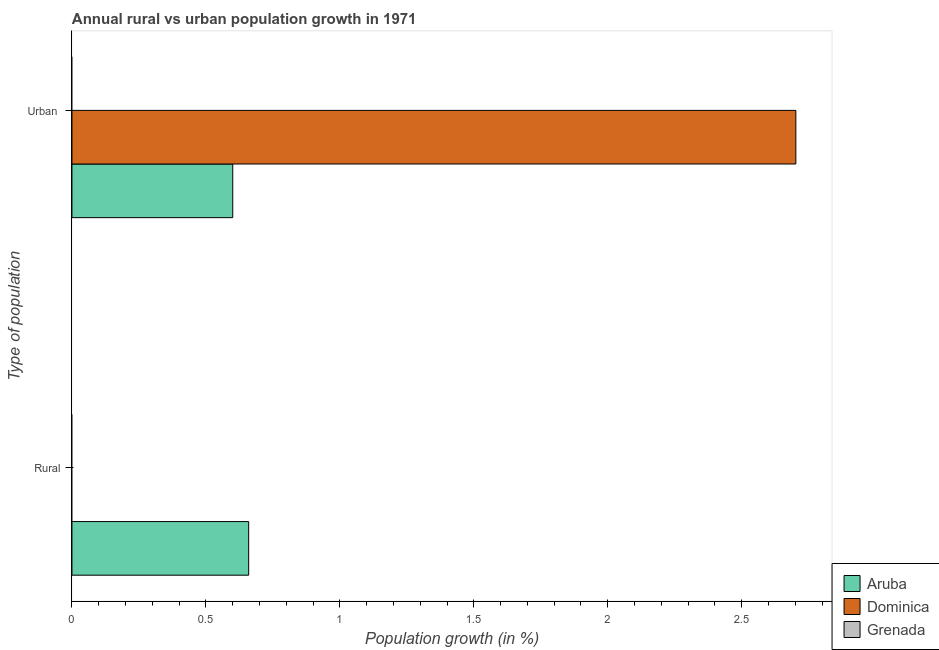Are the number of bars per tick equal to the number of legend labels?
Provide a succinct answer. No. What is the label of the 1st group of bars from the top?
Provide a succinct answer. Urban . Across all countries, what is the maximum rural population growth?
Offer a very short reply. 0.66. In which country was the urban population growth maximum?
Provide a succinct answer. Dominica. What is the total urban population growth in the graph?
Keep it short and to the point. 3.3. What is the difference between the urban population growth in Aruba and that in Dominica?
Your response must be concise. -2.1. What is the difference between the rural population growth in Grenada and the urban population growth in Aruba?
Your answer should be very brief. -0.6. What is the average rural population growth per country?
Give a very brief answer. 0.22. In how many countries, is the rural population growth greater than 0.4 %?
Your answer should be very brief. 1. What is the ratio of the urban population growth in Dominica to that in Aruba?
Provide a short and direct response. 4.5. Is the urban population growth in Aruba less than that in Dominica?
Offer a terse response. Yes. How many bars are there?
Provide a succinct answer. 3. Are all the bars in the graph horizontal?
Ensure brevity in your answer.  Yes. How many countries are there in the graph?
Make the answer very short. 3. Are the values on the major ticks of X-axis written in scientific E-notation?
Your answer should be very brief. No. Does the graph contain any zero values?
Your answer should be very brief. Yes. Where does the legend appear in the graph?
Your answer should be very brief. Bottom right. What is the title of the graph?
Provide a succinct answer. Annual rural vs urban population growth in 1971. Does "Low income" appear as one of the legend labels in the graph?
Offer a terse response. No. What is the label or title of the X-axis?
Provide a short and direct response. Population growth (in %). What is the label or title of the Y-axis?
Provide a succinct answer. Type of population. What is the Population growth (in %) of Aruba in Rural?
Your response must be concise. 0.66. What is the Population growth (in %) of Aruba in Urban ?
Your answer should be compact. 0.6. What is the Population growth (in %) of Dominica in Urban ?
Keep it short and to the point. 2.7. Across all Type of population, what is the maximum Population growth (in %) of Aruba?
Provide a short and direct response. 0.66. Across all Type of population, what is the maximum Population growth (in %) of Dominica?
Your answer should be very brief. 2.7. Across all Type of population, what is the minimum Population growth (in %) in Aruba?
Provide a succinct answer. 0.6. What is the total Population growth (in %) in Aruba in the graph?
Make the answer very short. 1.26. What is the total Population growth (in %) of Dominica in the graph?
Make the answer very short. 2.7. What is the total Population growth (in %) in Grenada in the graph?
Make the answer very short. 0. What is the difference between the Population growth (in %) of Aruba in Rural and that in Urban ?
Provide a short and direct response. 0.06. What is the difference between the Population growth (in %) of Aruba in Rural and the Population growth (in %) of Dominica in Urban ?
Offer a terse response. -2.04. What is the average Population growth (in %) of Aruba per Type of population?
Offer a very short reply. 0.63. What is the average Population growth (in %) in Dominica per Type of population?
Offer a very short reply. 1.35. What is the average Population growth (in %) in Grenada per Type of population?
Give a very brief answer. 0. What is the difference between the Population growth (in %) in Aruba and Population growth (in %) in Dominica in Urban ?
Offer a very short reply. -2.1. What is the ratio of the Population growth (in %) in Aruba in Rural to that in Urban ?
Offer a very short reply. 1.1. What is the difference between the highest and the second highest Population growth (in %) in Aruba?
Your answer should be very brief. 0.06. What is the difference between the highest and the lowest Population growth (in %) in Aruba?
Your answer should be compact. 0.06. What is the difference between the highest and the lowest Population growth (in %) of Dominica?
Provide a succinct answer. 2.7. 